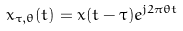<formula> <loc_0><loc_0><loc_500><loc_500>x _ { \tau , \theta } ( t ) = x ( t - \tau ) e ^ { j 2 \pi \theta t }</formula> 